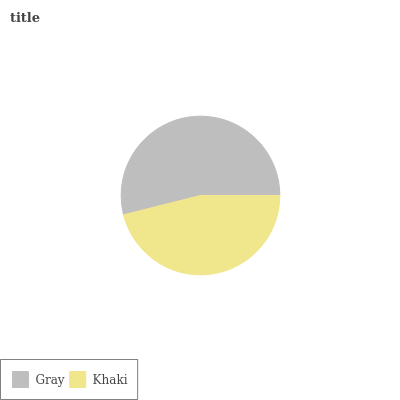Is Khaki the minimum?
Answer yes or no. Yes. Is Gray the maximum?
Answer yes or no. Yes. Is Khaki the maximum?
Answer yes or no. No. Is Gray greater than Khaki?
Answer yes or no. Yes. Is Khaki less than Gray?
Answer yes or no. Yes. Is Khaki greater than Gray?
Answer yes or no. No. Is Gray less than Khaki?
Answer yes or no. No. Is Gray the high median?
Answer yes or no. Yes. Is Khaki the low median?
Answer yes or no. Yes. Is Khaki the high median?
Answer yes or no. No. Is Gray the low median?
Answer yes or no. No. 